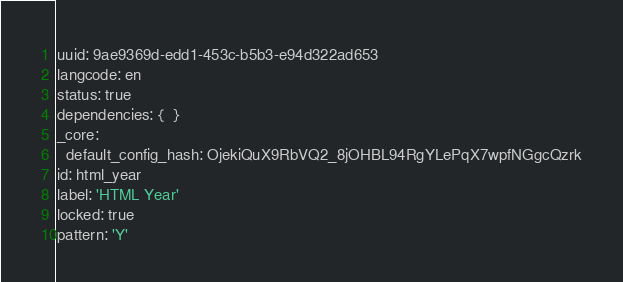<code> <loc_0><loc_0><loc_500><loc_500><_YAML_>uuid: 9ae9369d-edd1-453c-b5b3-e94d322ad653
langcode: en
status: true
dependencies: {  }
_core:
  default_config_hash: OjekiQuX9RbVQ2_8jOHBL94RgYLePqX7wpfNGgcQzrk
id: html_year
label: 'HTML Year'
locked: true
pattern: 'Y'
</code> 